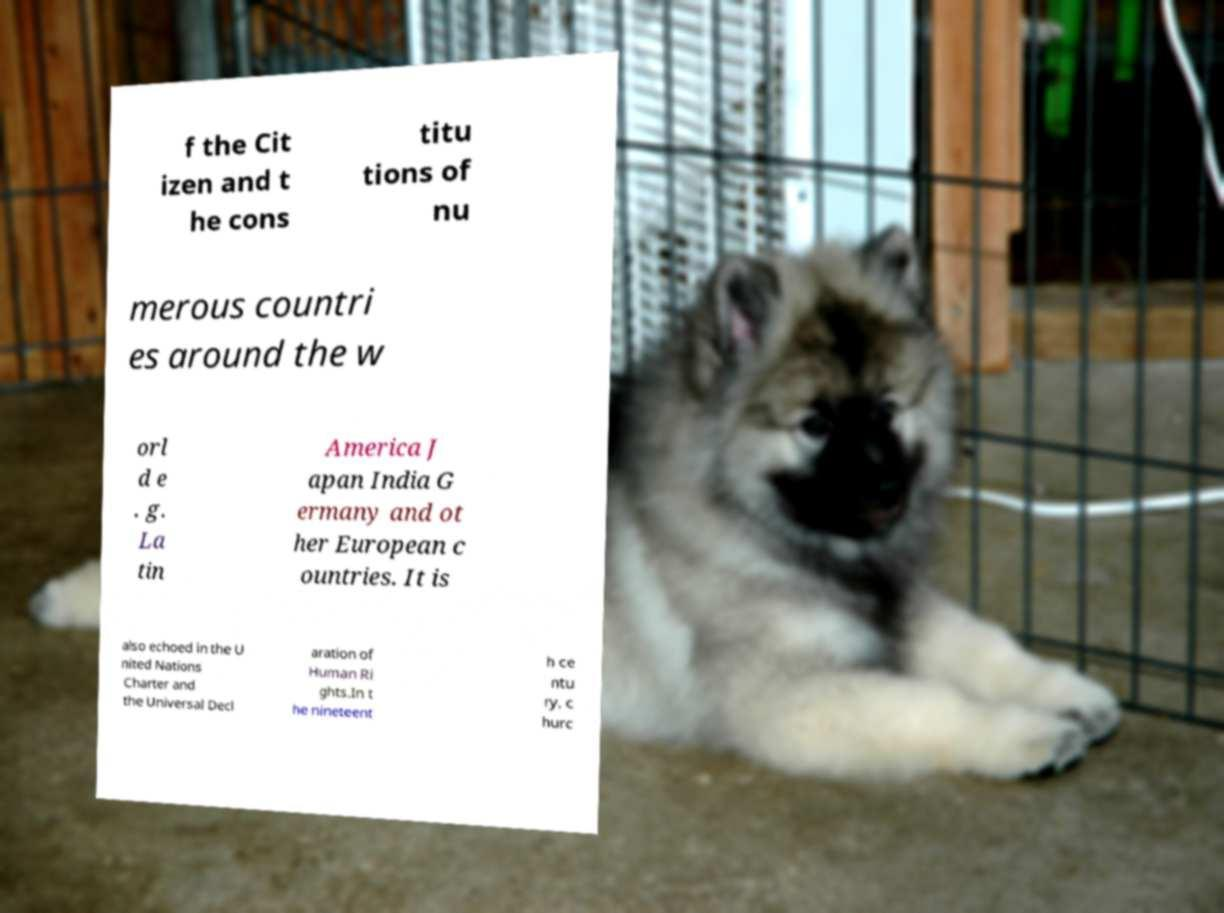Please identify and transcribe the text found in this image. f the Cit izen and t he cons titu tions of nu merous countri es around the w orl d e . g. La tin America J apan India G ermany and ot her European c ountries. It is also echoed in the U nited Nations Charter and the Universal Decl aration of Human Ri ghts.In t he nineteent h ce ntu ry, c hurc 